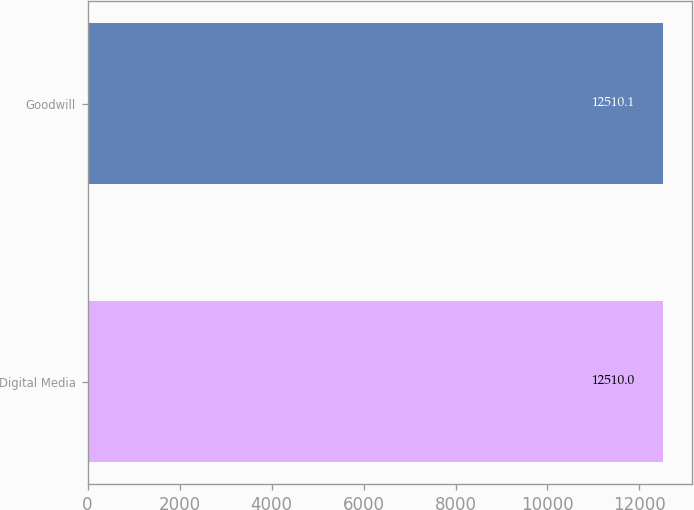Convert chart to OTSL. <chart><loc_0><loc_0><loc_500><loc_500><bar_chart><fcel>Digital Media<fcel>Goodwill<nl><fcel>12510<fcel>12510.1<nl></chart> 